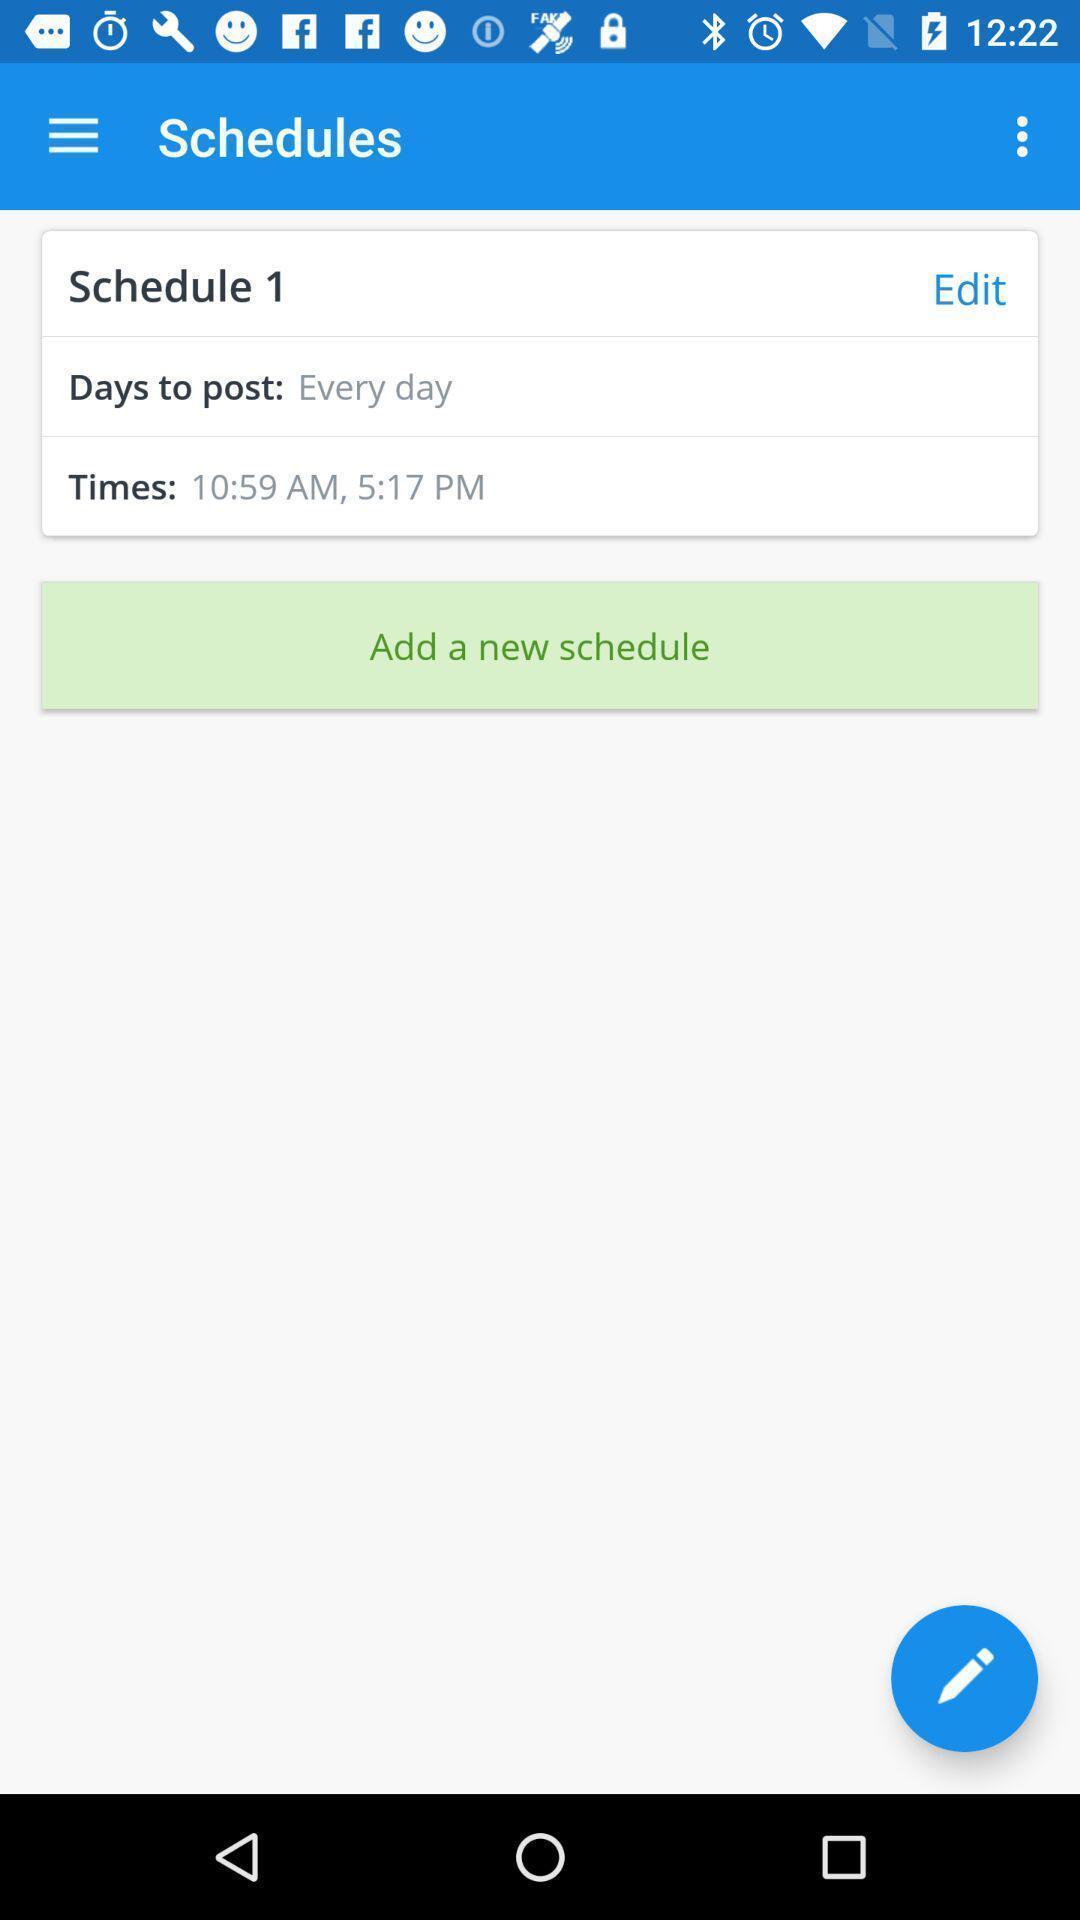What details can you identify in this image? Screen shows the schedule posts. 